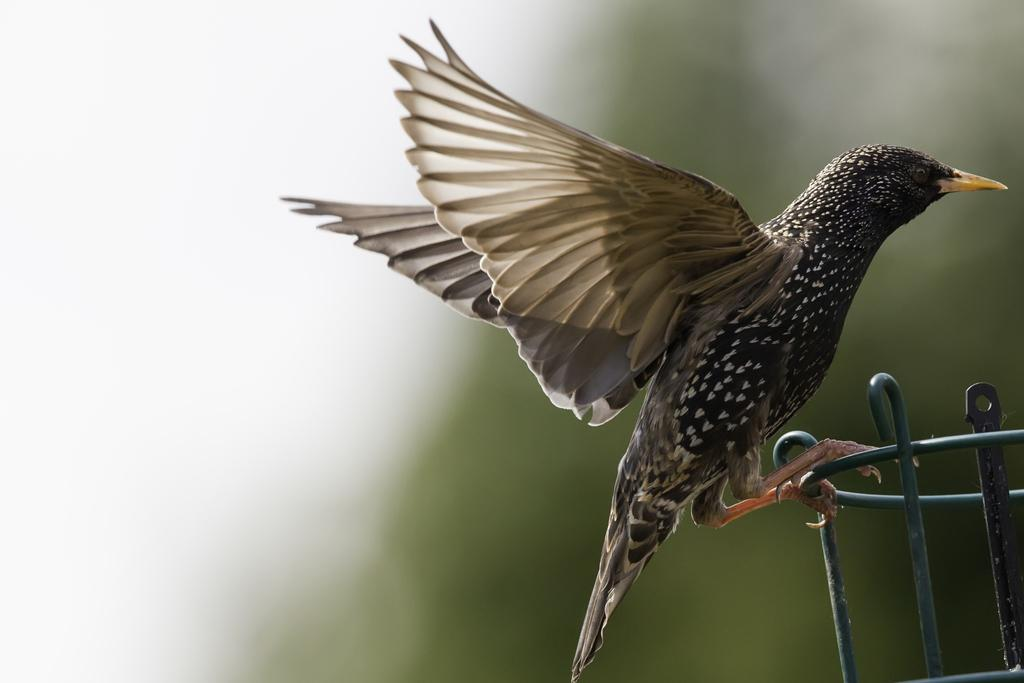What type of animal is in the image? There is a bird in the image. Where is the bird located? The bird is on a stand. Can you describe the background of the image? The background of the image is blurry. What example of an hour can be seen in the image? There is no hour or time-related element present in the image; it features a bird on a stand with a blurry background. 